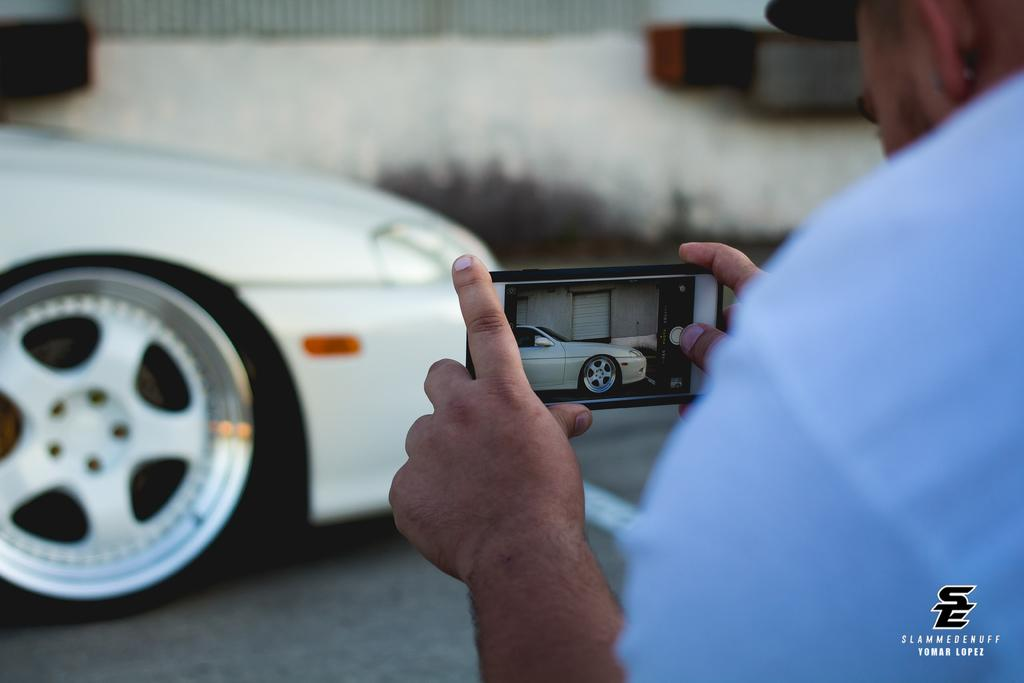Who is present in the image? There is a man in the image. Where is the man located in the image? The man is on the right side of the image. What is the man doing in the image? The man is capturing an image with a mobile phone. What else can be seen in the image? There is a car in the image. Where is the car located in the image? The car is on the left side of the image. What is the car's location in relation to the road? The car is on a road. What type of riddle is the man trying to solve in the image? There is no riddle present in the image; the man is capturing an image with a mobile phone. How many pets are visible in the image? There are no pets visible in the image. 